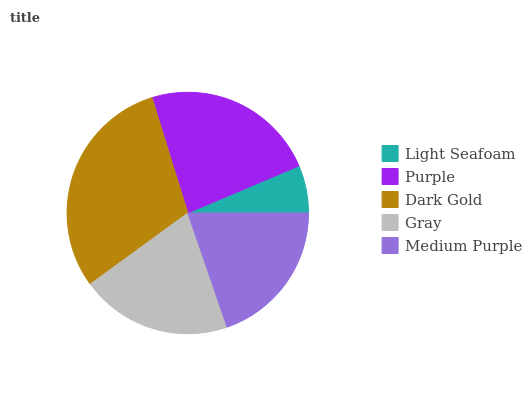Is Light Seafoam the minimum?
Answer yes or no. Yes. Is Dark Gold the maximum?
Answer yes or no. Yes. Is Purple the minimum?
Answer yes or no. No. Is Purple the maximum?
Answer yes or no. No. Is Purple greater than Light Seafoam?
Answer yes or no. Yes. Is Light Seafoam less than Purple?
Answer yes or no. Yes. Is Light Seafoam greater than Purple?
Answer yes or no. No. Is Purple less than Light Seafoam?
Answer yes or no. No. Is Gray the high median?
Answer yes or no. Yes. Is Gray the low median?
Answer yes or no. Yes. Is Light Seafoam the high median?
Answer yes or no. No. Is Medium Purple the low median?
Answer yes or no. No. 